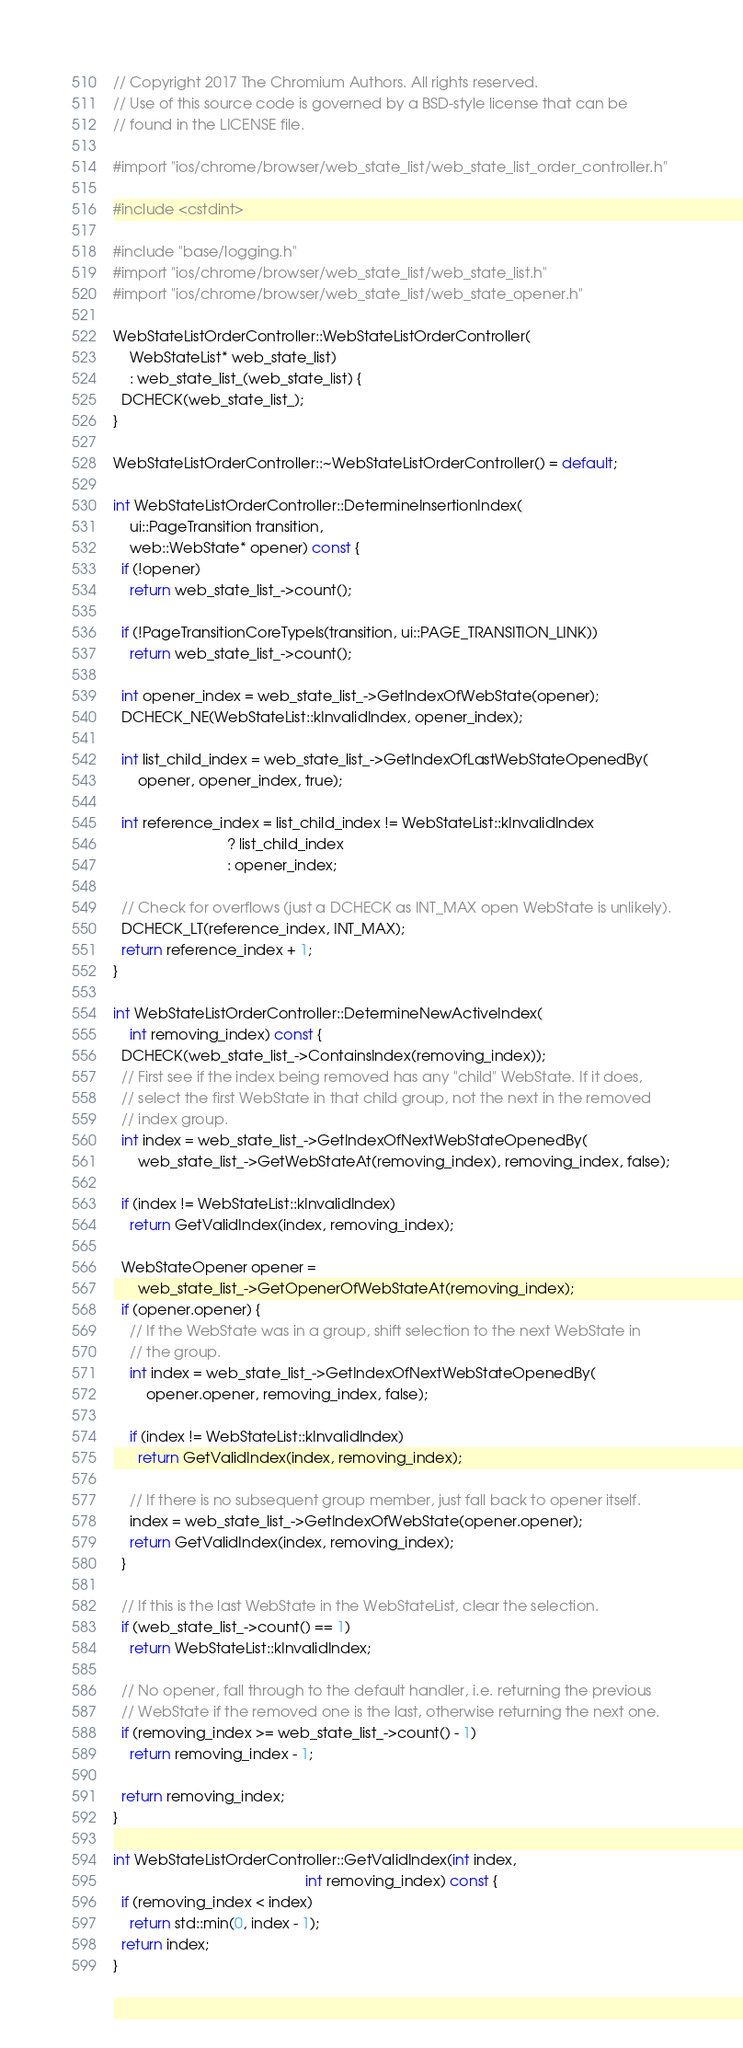Convert code to text. <code><loc_0><loc_0><loc_500><loc_500><_ObjectiveC_>// Copyright 2017 The Chromium Authors. All rights reserved.
// Use of this source code is governed by a BSD-style license that can be
// found in the LICENSE file.

#import "ios/chrome/browser/web_state_list/web_state_list_order_controller.h"

#include <cstdint>

#include "base/logging.h"
#import "ios/chrome/browser/web_state_list/web_state_list.h"
#import "ios/chrome/browser/web_state_list/web_state_opener.h"

WebStateListOrderController::WebStateListOrderController(
    WebStateList* web_state_list)
    : web_state_list_(web_state_list) {
  DCHECK(web_state_list_);
}

WebStateListOrderController::~WebStateListOrderController() = default;

int WebStateListOrderController::DetermineInsertionIndex(
    ui::PageTransition transition,
    web::WebState* opener) const {
  if (!opener)
    return web_state_list_->count();

  if (!PageTransitionCoreTypeIs(transition, ui::PAGE_TRANSITION_LINK))
    return web_state_list_->count();

  int opener_index = web_state_list_->GetIndexOfWebState(opener);
  DCHECK_NE(WebStateList::kInvalidIndex, opener_index);

  int list_child_index = web_state_list_->GetIndexOfLastWebStateOpenedBy(
      opener, opener_index, true);

  int reference_index = list_child_index != WebStateList::kInvalidIndex
                            ? list_child_index
                            : opener_index;

  // Check for overflows (just a DCHECK as INT_MAX open WebState is unlikely).
  DCHECK_LT(reference_index, INT_MAX);
  return reference_index + 1;
}

int WebStateListOrderController::DetermineNewActiveIndex(
    int removing_index) const {
  DCHECK(web_state_list_->ContainsIndex(removing_index));
  // First see if the index being removed has any "child" WebState. If it does,
  // select the first WebState in that child group, not the next in the removed
  // index group.
  int index = web_state_list_->GetIndexOfNextWebStateOpenedBy(
      web_state_list_->GetWebStateAt(removing_index), removing_index, false);

  if (index != WebStateList::kInvalidIndex)
    return GetValidIndex(index, removing_index);

  WebStateOpener opener =
      web_state_list_->GetOpenerOfWebStateAt(removing_index);
  if (opener.opener) {
    // If the WebState was in a group, shift selection to the next WebState in
    // the group.
    int index = web_state_list_->GetIndexOfNextWebStateOpenedBy(
        opener.opener, removing_index, false);

    if (index != WebStateList::kInvalidIndex)
      return GetValidIndex(index, removing_index);

    // If there is no subsequent group member, just fall back to opener itself.
    index = web_state_list_->GetIndexOfWebState(opener.opener);
    return GetValidIndex(index, removing_index);
  }

  // If this is the last WebState in the WebStateList, clear the selection.
  if (web_state_list_->count() == 1)
    return WebStateList::kInvalidIndex;

  // No opener, fall through to the default handler, i.e. returning the previous
  // WebState if the removed one is the last, otherwise returning the next one.
  if (removing_index >= web_state_list_->count() - 1)
    return removing_index - 1;

  return removing_index;
}

int WebStateListOrderController::GetValidIndex(int index,
                                               int removing_index) const {
  if (removing_index < index)
    return std::min(0, index - 1);
  return index;
}
</code> 